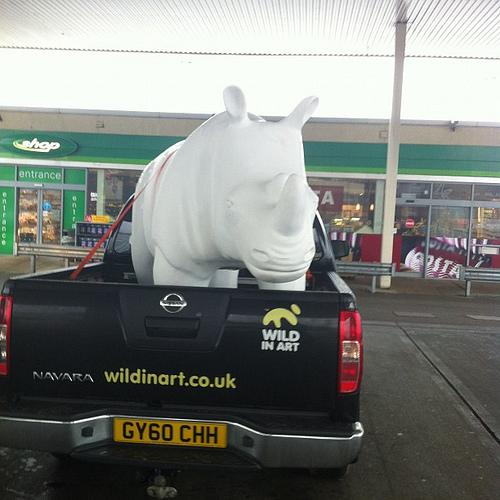Question: what kind of statue is in the truck?
Choices:
A. Elephant.
B. Rhinoceros.
C. Shark.
D. Horse.
Answer with the letter. Answer: B Question: where are the words "Wild In Art"?
Choices:
A. Sticker.
B. A picture title.
C. At the zoo.
D. Tail gate.
Answer with the letter. Answer: D 